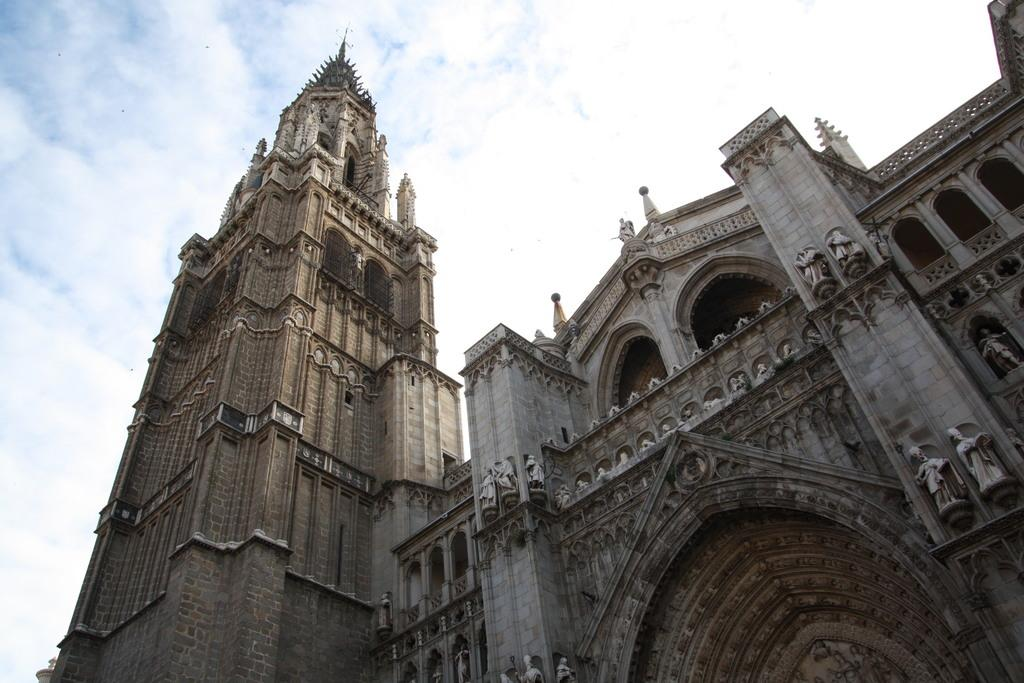What type of structure is visible in the image? There is a building in the image. What features can be observed on the building? The building has engravings and statues. What is visible in the sky at the top of the image? There are clouds in the sky at the top of the image. What type of farm animals can be seen grazing in the image? There is no farm or farm animals present in the image; it features a building with engravings and statues. What is the chance of winning a prize in the image? There is no reference to a prize or any game of chance in the image. 